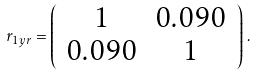<formula> <loc_0><loc_0><loc_500><loc_500>r _ { 1 y r } = \left ( \begin{array} { c c } 1 & 0 . 0 9 0 \\ 0 . 0 9 0 & 1 \end{array} \right ) \, .</formula> 